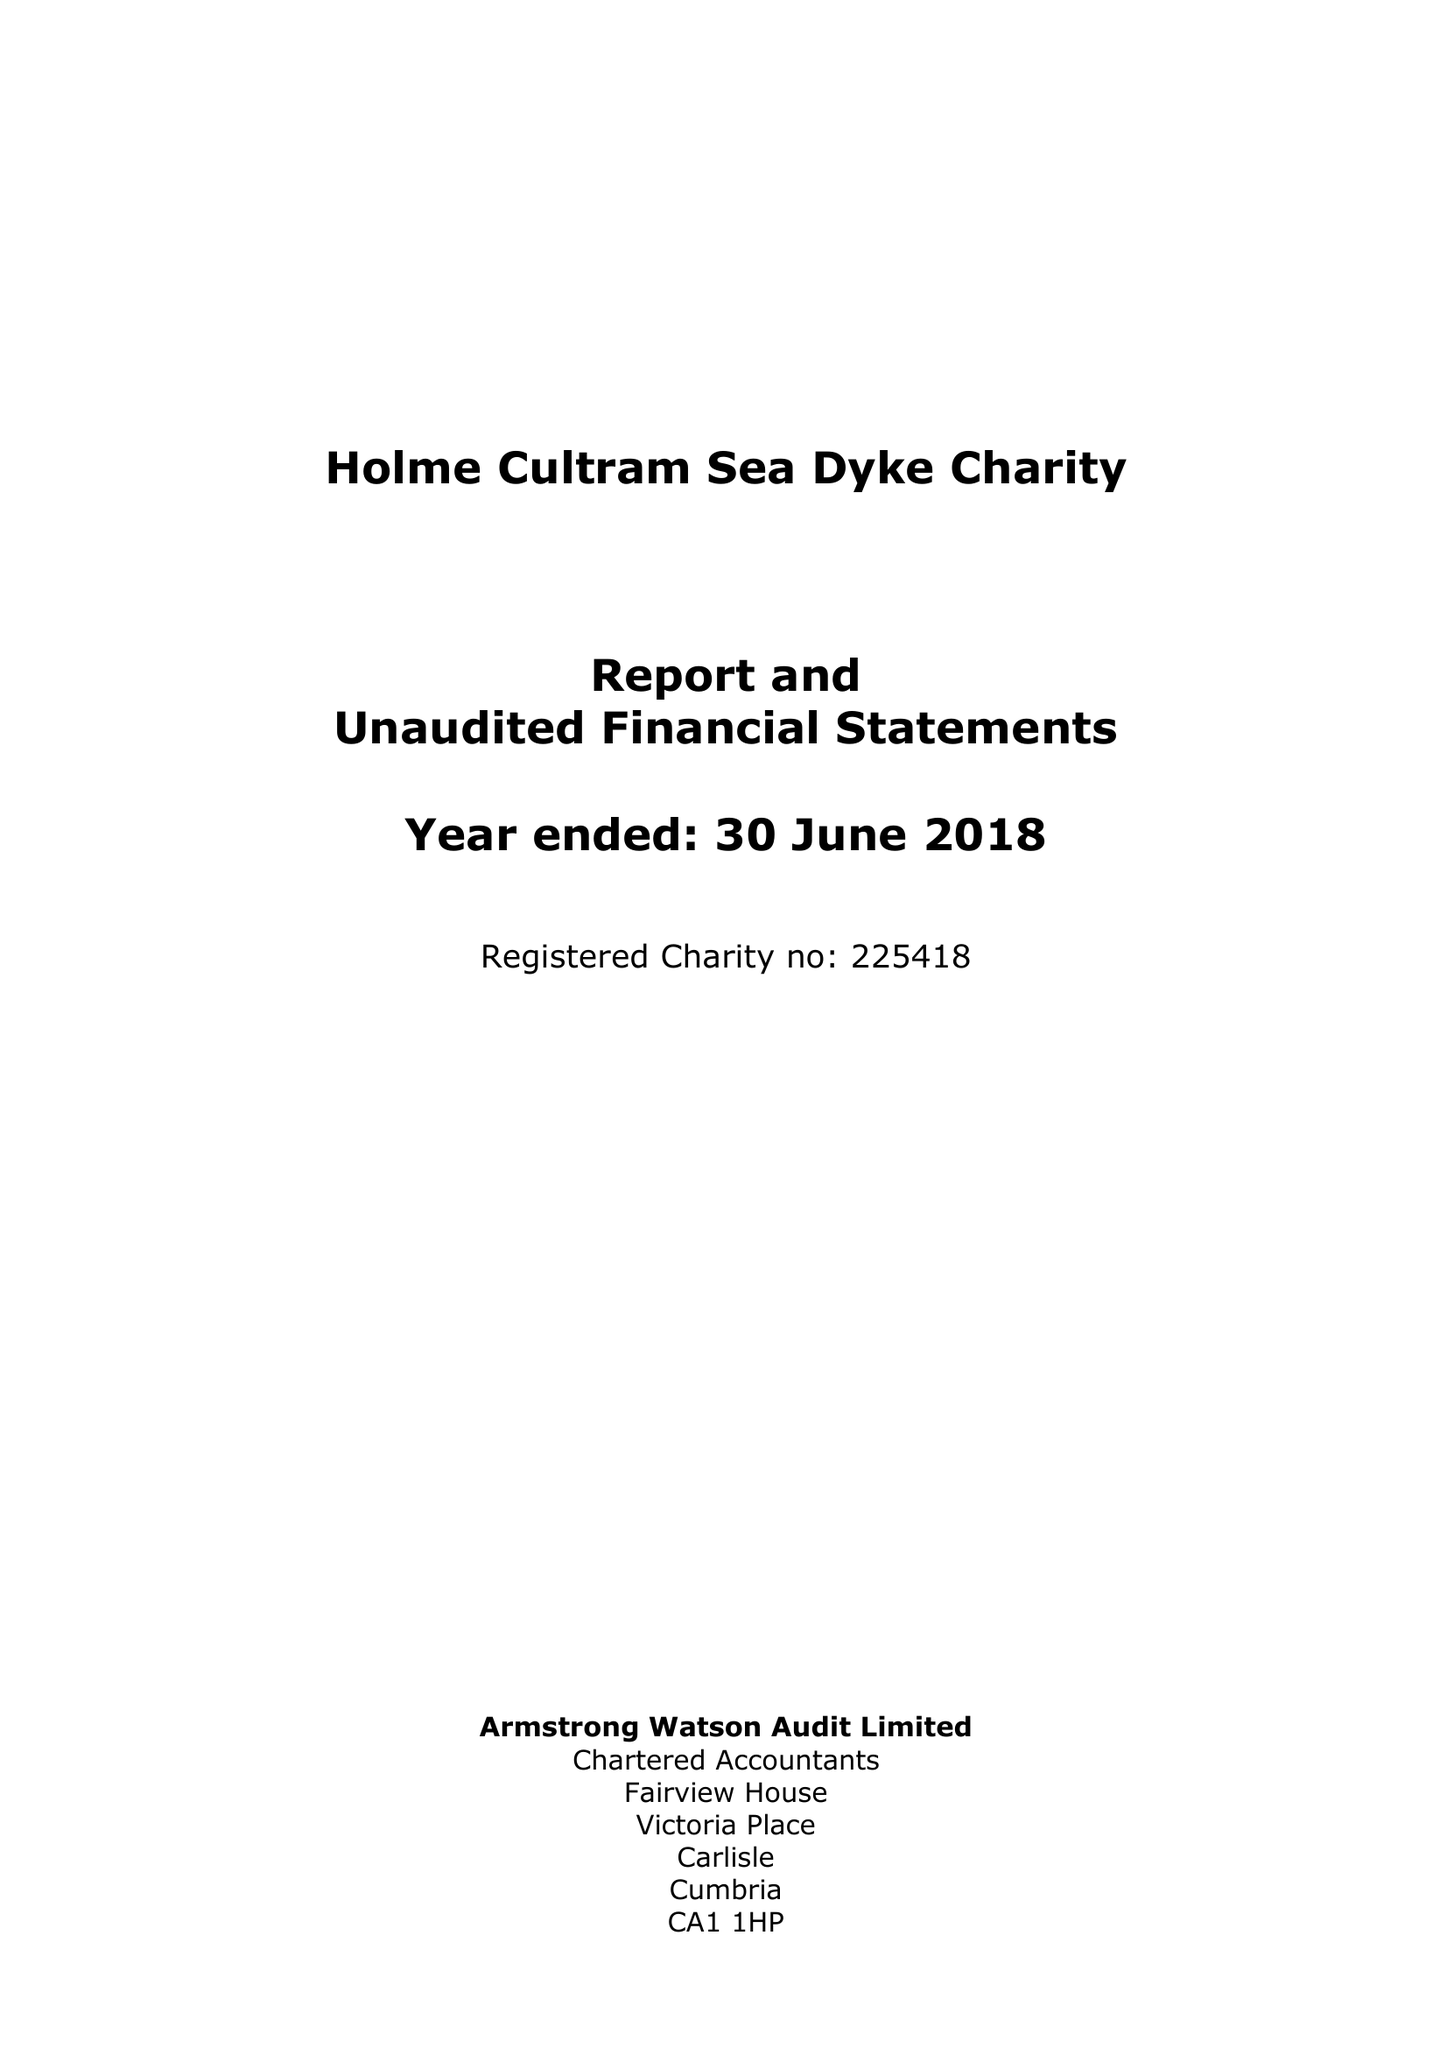What is the value for the charity_name?
Answer the question using a single word or phrase. The Holme Cultram Sea Dyke Charity 